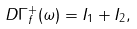Convert formula to latex. <formula><loc_0><loc_0><loc_500><loc_500>D \Gamma _ { f } ^ { + } ( \omega ) = I _ { 1 } + I _ { 2 } ,</formula> 